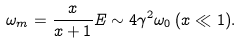Convert formula to latex. <formula><loc_0><loc_0><loc_500><loc_500>\omega _ { m } = \frac { x } { x + 1 } E \sim 4 \gamma ^ { 2 } \omega _ { 0 } \, ( x \ll 1 ) .</formula> 